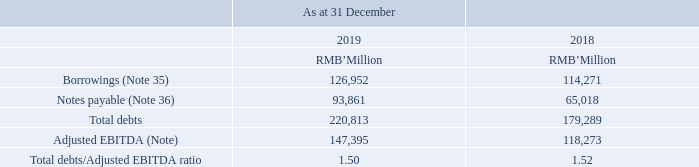3.2 Capital risk management
The Group’s objectives on managing capital are to safeguard the Group’s ability to continue as a going concern and support the sustainable growth of the Group in order to provide returns for shareholders and benefits for other stakeholders and to maintain an optimal capital structure to enhance shareholders’ value in the long term.
Capital refers to equity and external debts (including borrowings and notes payable). In order to maintain or adjust the capital structure, the Group may adjust the amount of dividends paid to shareholders, return capital to shareholders, issue new shares, repurchase the Company’s shares or raise/repay debts.
The Group monitors capital by regularly reviewing debts to adjusted earnings before interest, tax, depreciation and amortisation (“EBITDA”) (Note) ratio, being the measure of the Group’s ability to pay off all debts that reflects financial health and liquidity position. The total debts/adjusted EBITDA ratio calculated by dividing the total debts by adjusted EBITDA is as follows:
Note: Adjusted EBITDA represents operating profit less interest income and other gains/(losses), net, and adding back depreciation of property, plant and equipment, investment properties as well as right-of-use assets, amortisation of intangible assets and equitysettled share-based compensation expenses.
What is the amount of borrowings as at 31 December 2019?
Answer scale should be: million. 126,952. What is the amount of borrowings as at 31 December 2018?
Answer scale should be: million. 114,271. What is the amount of notes payable as at 31 December 2019?
Answer scale should be: million. 93,861. How much did borrowings change from 2018 year end to 2019 year end?
Answer scale should be: million. 126,952-114,271
Answer: 12681. How much did notes payable change from 2018 year end to 2019 year end?
Answer scale should be: million. 93,861-65,018
Answer: 28843. How much did the Adjusted EBITDA change  from 2018 year end to 2019 year end?
Answer scale should be: million. 147,395-118,273
Answer: 29122. 